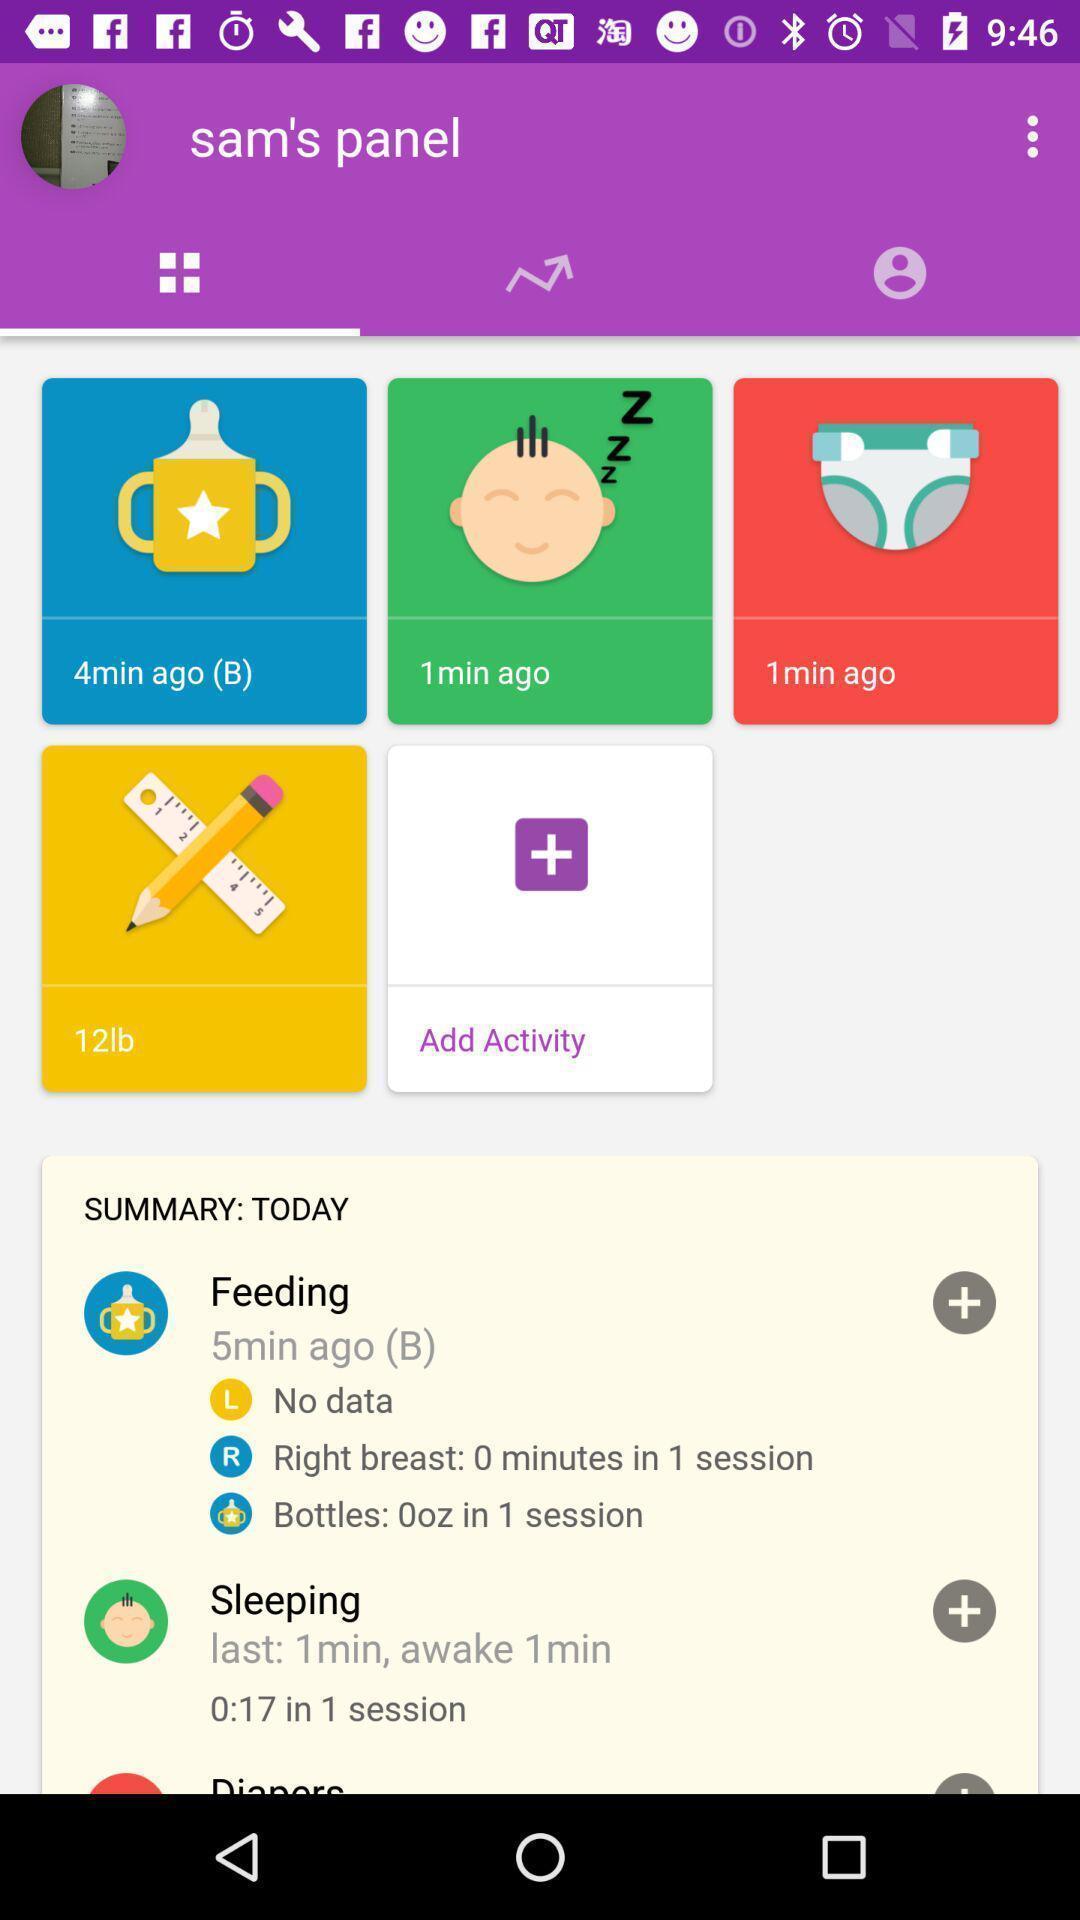Tell me about the visual elements in this screen capture. Screen displaying timings of feeding application. 